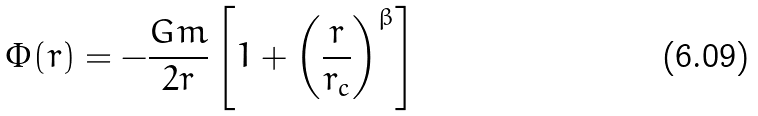<formula> <loc_0><loc_0><loc_500><loc_500>\Phi ( r ) = - \frac { G m } { 2 r } \left [ 1 + \left ( \frac { r } { r _ { c } } \right ) ^ { \beta } \right ]</formula> 